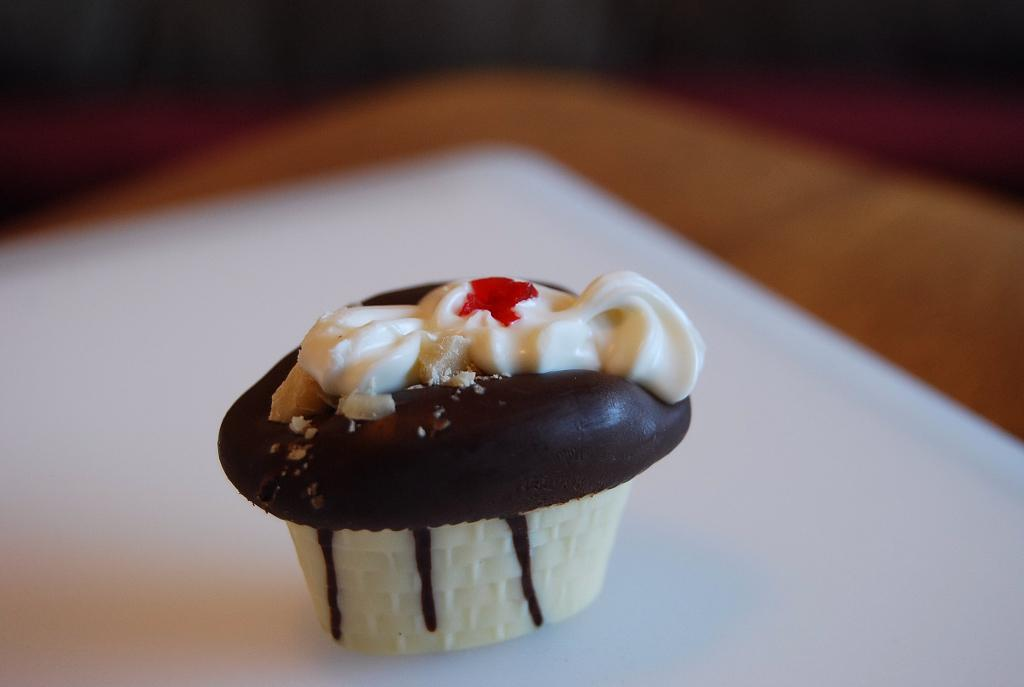What is on the plate that is visible in the image? There is a food item on the plate. What can be seen in the image besides the plate and food item? The background of the image is blurred. How many beads are scattered around the plate in the image? There are no beads present in the image. What note is written on the plate in the image? There is no note written on the plate in the image. 